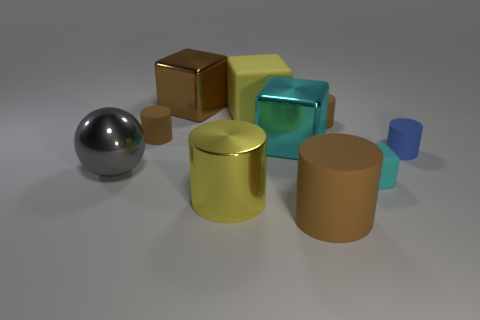Subtract all cyan metal cubes. How many cubes are left? 3 Subtract all yellow blocks. How many blocks are left? 3 Subtract all balls. How many objects are left? 9 Subtract 1 cubes. How many cubes are left? 3 Subtract 0 green spheres. How many objects are left? 10 Subtract all brown spheres. Subtract all yellow cylinders. How many spheres are left? 1 Subtract all yellow cylinders. How many purple blocks are left? 0 Subtract all yellow cubes. Subtract all metal balls. How many objects are left? 8 Add 5 tiny blue matte objects. How many tiny blue matte objects are left? 6 Add 7 big brown objects. How many big brown objects exist? 9 